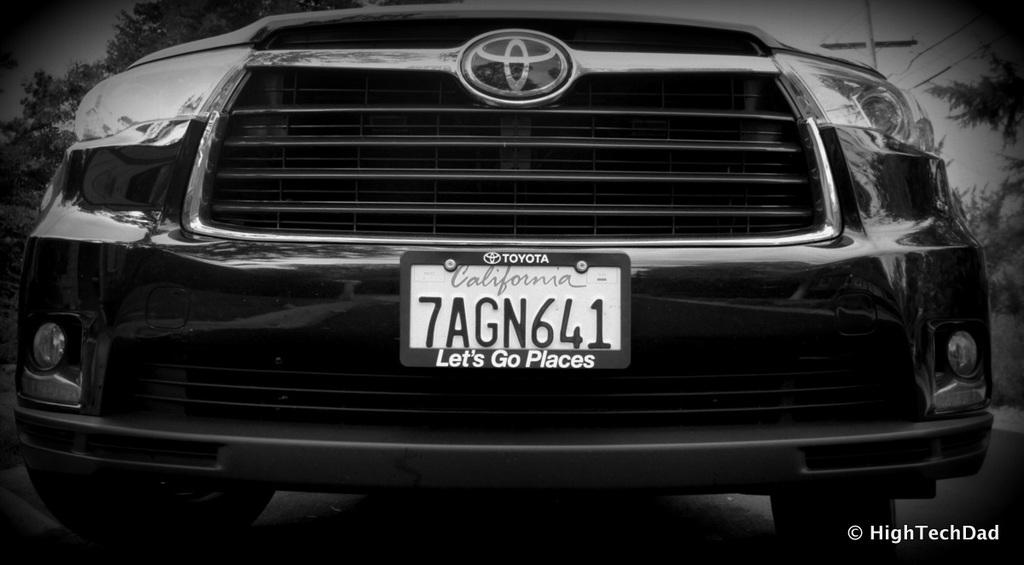What is the main subject in the center of the image? There is a car in the center of the image. What can be seen in the background of the image? There are trees and a pole in the background of the image. What type of skin condition is visible on the car in the image? There is no skin condition present on the car in the image, as cars do not have skin. 